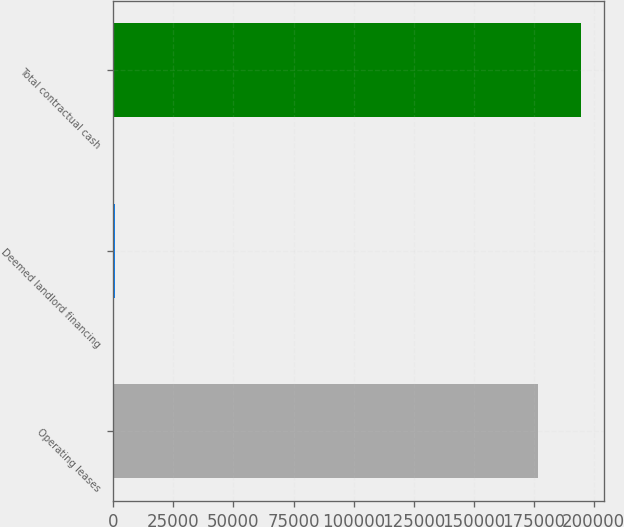Convert chart. <chart><loc_0><loc_0><loc_500><loc_500><bar_chart><fcel>Operating leases<fcel>Deemed landlord financing<fcel>Total contractual cash<nl><fcel>176929<fcel>764<fcel>194675<nl></chart> 